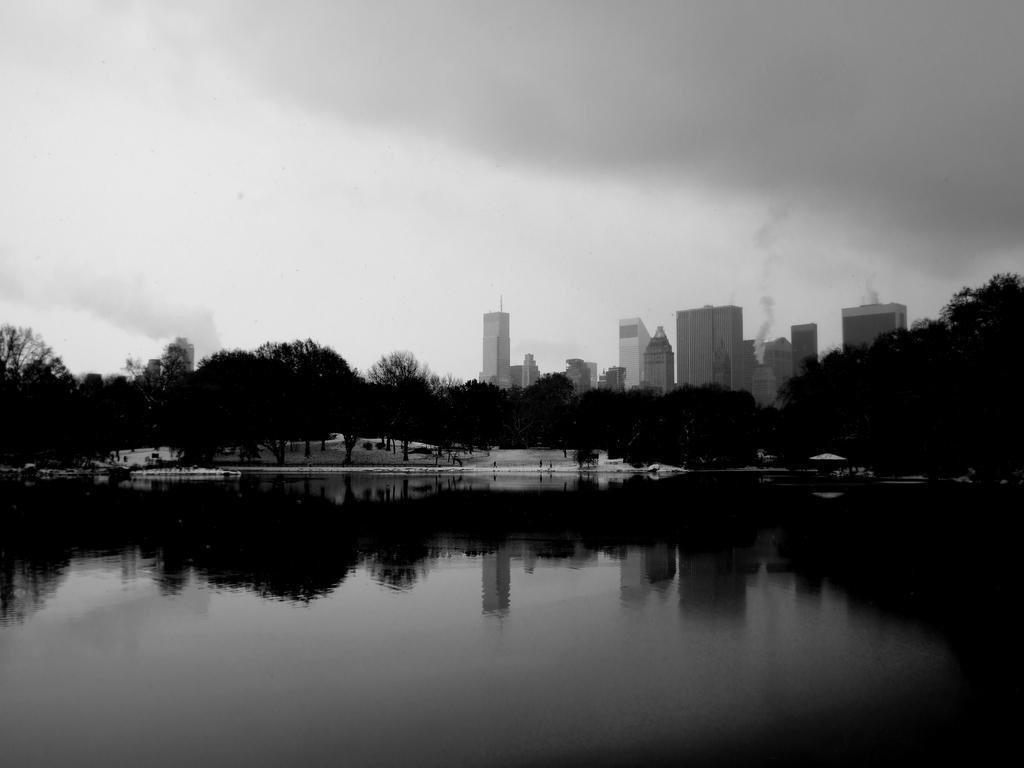In one or two sentences, can you explain what this image depicts? This is a black and white image. In this image we can see water. In the back there are trees and buildings. Also there is smoke coming from buildings. And there is sky. 